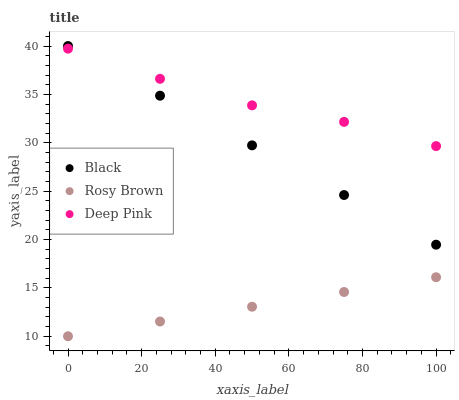Does Rosy Brown have the minimum area under the curve?
Answer yes or no. Yes. Does Deep Pink have the maximum area under the curve?
Answer yes or no. Yes. Does Black have the minimum area under the curve?
Answer yes or no. No. Does Black have the maximum area under the curve?
Answer yes or no. No. Is Rosy Brown the smoothest?
Answer yes or no. Yes. Is Deep Pink the roughest?
Answer yes or no. Yes. Is Black the smoothest?
Answer yes or no. No. Is Black the roughest?
Answer yes or no. No. Does Rosy Brown have the lowest value?
Answer yes or no. Yes. Does Black have the lowest value?
Answer yes or no. No. Does Black have the highest value?
Answer yes or no. Yes. Does Deep Pink have the highest value?
Answer yes or no. No. Is Rosy Brown less than Deep Pink?
Answer yes or no. Yes. Is Black greater than Rosy Brown?
Answer yes or no. Yes. Does Deep Pink intersect Black?
Answer yes or no. Yes. Is Deep Pink less than Black?
Answer yes or no. No. Is Deep Pink greater than Black?
Answer yes or no. No. Does Rosy Brown intersect Deep Pink?
Answer yes or no. No. 